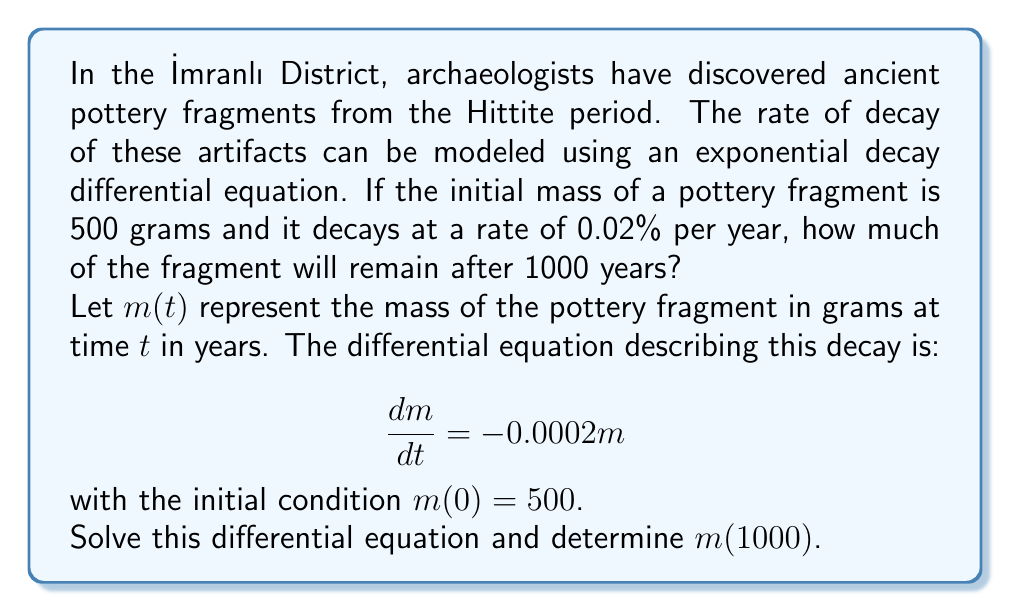Can you solve this math problem? To solve this problem, we'll follow these steps:

1) The general form of an exponential decay differential equation is:
   $$\frac{dm}{dt} = km$$
   where $k$ is the decay constant. In this case, $k = -0.0002$.

2) The solution to this differential equation is:
   $$m(t) = Ce^{kt}$$
   where $C$ is a constant we need to determine using the initial condition.

3) Using the initial condition $m(0) = 500$:
   $$500 = Ce^{k(0)} = C$$

4) So our solution is:
   $$m(t) = 500e^{-0.0002t}$$

5) To find the mass after 1000 years, we calculate $m(1000)$:
   $$m(1000) = 500e^{-0.0002(1000)}$$

6) Let's evaluate this:
   $$m(1000) = 500e^{-0.2} = 500 \cdot (0.8187) \approx 409.35$$

Therefore, after 1000 years, approximately 409.35 grams of the pottery fragment will remain.
Answer: $m(1000) \approx 409.35$ grams 